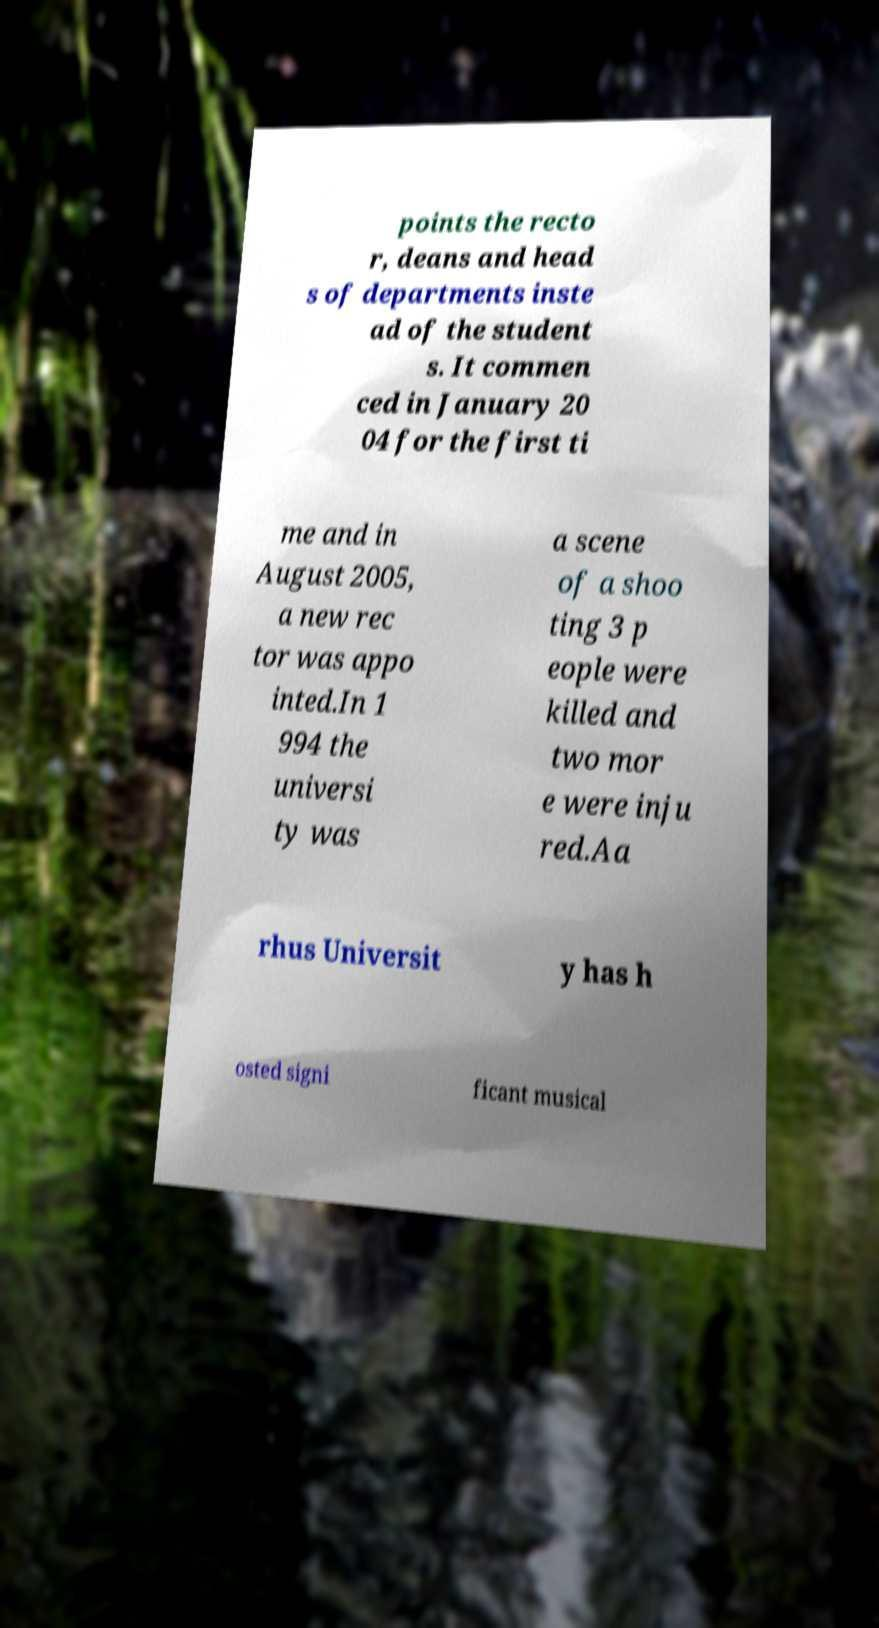Can you read and provide the text displayed in the image?This photo seems to have some interesting text. Can you extract and type it out for me? points the recto r, deans and head s of departments inste ad of the student s. It commen ced in January 20 04 for the first ti me and in August 2005, a new rec tor was appo inted.In 1 994 the universi ty was a scene of a shoo ting 3 p eople were killed and two mor e were inju red.Aa rhus Universit y has h osted signi ficant musical 